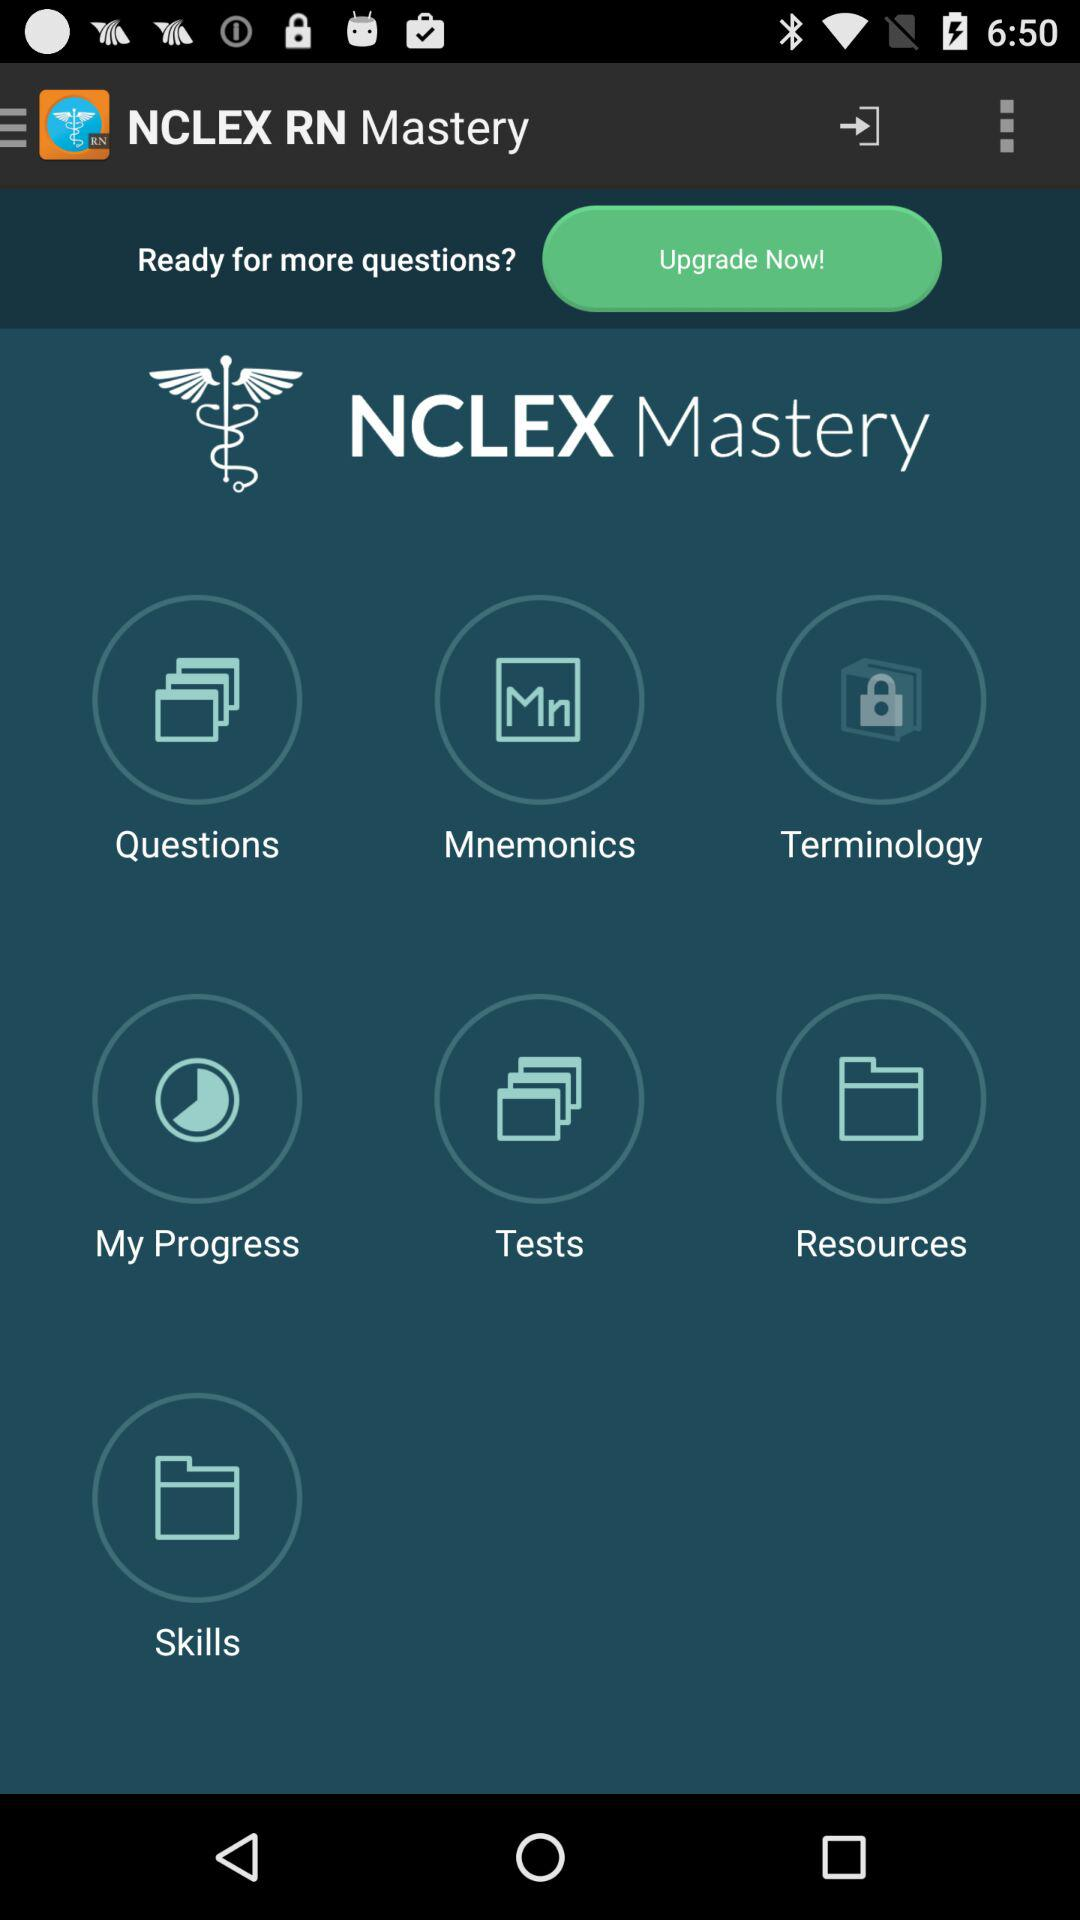What is the application name? The application name is "NCLEX RN Mastery". 